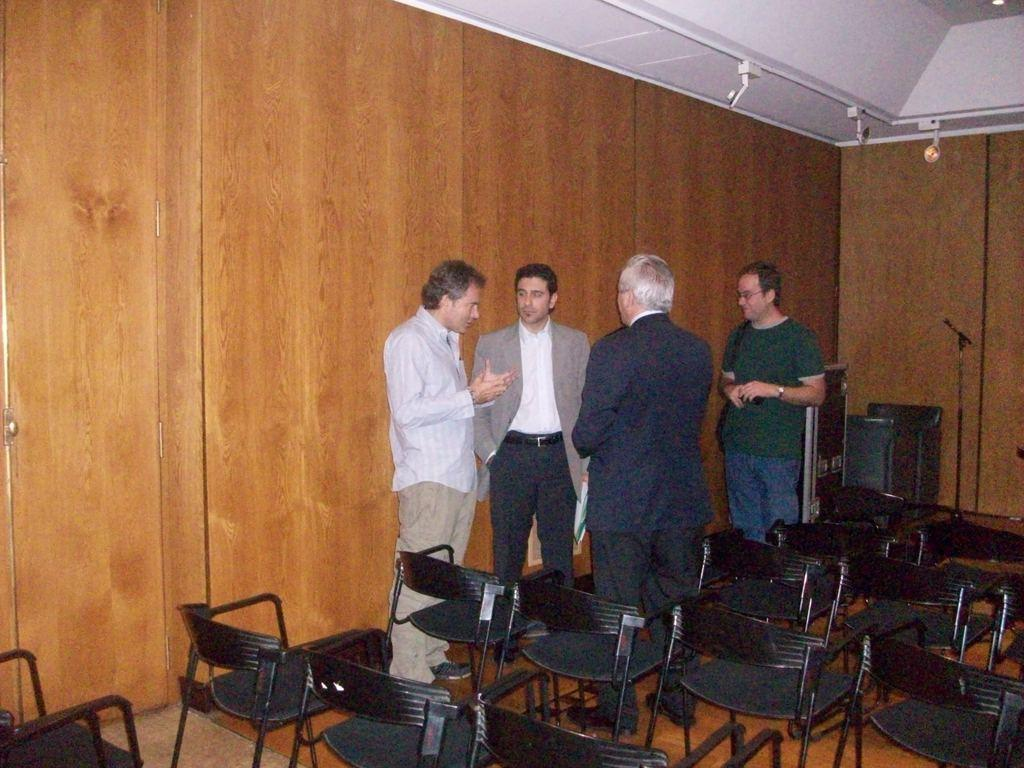What are the people in the image doing? The persons standing on the floor in the image are likely engaged in some activity or standing in a particular setting. What objects are present at the bottom of the image? Chairs are visible at the bottom of the image. What can be seen in the background of the image? There is a wall and a mic in the background of the image. How many cherries are on the persons' heads in the image? There are no cherries present on the persons' heads in the image. What is the process used to create the mic in the background of the image? The image does not provide information about the process used to create the mic; it only shows its presence in the background. 